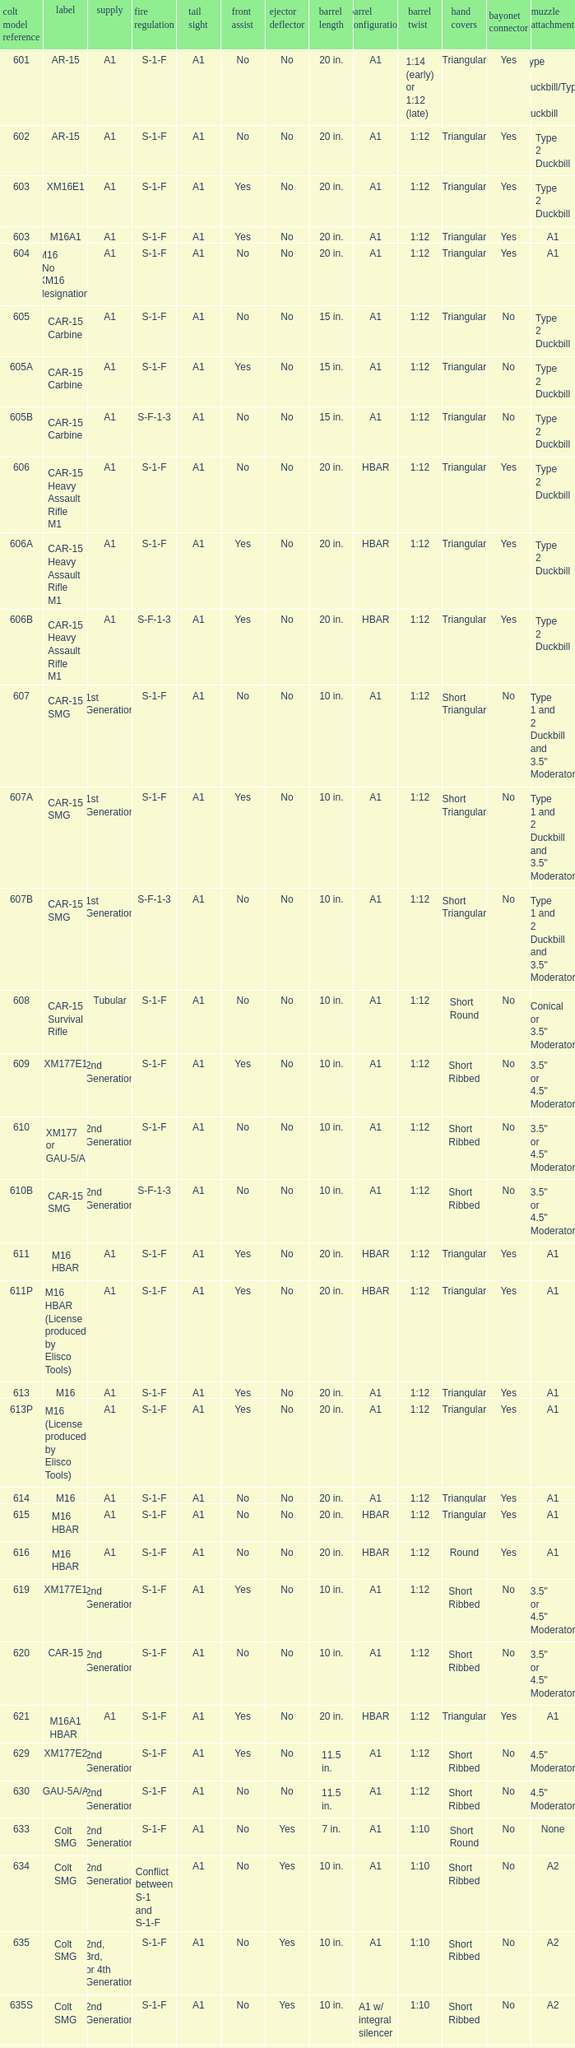What are the Colt model numbers of the models named GAU-5A/A, with no bayonet lug, no case deflector and stock of 2nd generation?  630, 649. Could you help me parse every detail presented in this table? {'header': ['colt model reference', 'label', 'supply', 'fire regulation', 'tail sight', 'front assist', 'ejector deflector', 'barrel length', 'barrel configuration', 'barrel twist', 'hand covers', 'bayonet connector', 'muzzle attachment'], 'rows': [['601', 'AR-15', 'A1', 'S-1-F', 'A1', 'No', 'No', '20 in.', 'A1', '1:14 (early) or 1:12 (late)', 'Triangular', 'Yes', 'Type 1 Duckbill/Type 2 Duckbill'], ['602', 'AR-15', 'A1', 'S-1-F', 'A1', 'No', 'No', '20 in.', 'A1', '1:12', 'Triangular', 'Yes', 'Type 2 Duckbill'], ['603', 'XM16E1', 'A1', 'S-1-F', 'A1', 'Yes', 'No', '20 in.', 'A1', '1:12', 'Triangular', 'Yes', 'Type 2 Duckbill'], ['603', 'M16A1', 'A1', 'S-1-F', 'A1', 'Yes', 'No', '20 in.', 'A1', '1:12', 'Triangular', 'Yes', 'A1'], ['604', 'M16 (No XM16 designation)', 'A1', 'S-1-F', 'A1', 'No', 'No', '20 in.', 'A1', '1:12', 'Triangular', 'Yes', 'A1'], ['605', 'CAR-15 Carbine', 'A1', 'S-1-F', 'A1', 'No', 'No', '15 in.', 'A1', '1:12', 'Triangular', 'No', 'Type 2 Duckbill'], ['605A', 'CAR-15 Carbine', 'A1', 'S-1-F', 'A1', 'Yes', 'No', '15 in.', 'A1', '1:12', 'Triangular', 'No', 'Type 2 Duckbill'], ['605B', 'CAR-15 Carbine', 'A1', 'S-F-1-3', 'A1', 'No', 'No', '15 in.', 'A1', '1:12', 'Triangular', 'No', 'Type 2 Duckbill'], ['606', 'CAR-15 Heavy Assault Rifle M1', 'A1', 'S-1-F', 'A1', 'No', 'No', '20 in.', 'HBAR', '1:12', 'Triangular', 'Yes', 'Type 2 Duckbill'], ['606A', 'CAR-15 Heavy Assault Rifle M1', 'A1', 'S-1-F', 'A1', 'Yes', 'No', '20 in.', 'HBAR', '1:12', 'Triangular', 'Yes', 'Type 2 Duckbill'], ['606B', 'CAR-15 Heavy Assault Rifle M1', 'A1', 'S-F-1-3', 'A1', 'Yes', 'No', '20 in.', 'HBAR', '1:12', 'Triangular', 'Yes', 'Type 2 Duckbill'], ['607', 'CAR-15 SMG', '1st Generation', 'S-1-F', 'A1', 'No', 'No', '10 in.', 'A1', '1:12', 'Short Triangular', 'No', 'Type 1 and 2 Duckbill and 3.5" Moderator'], ['607A', 'CAR-15 SMG', '1st Generation', 'S-1-F', 'A1', 'Yes', 'No', '10 in.', 'A1', '1:12', 'Short Triangular', 'No', 'Type 1 and 2 Duckbill and 3.5" Moderator'], ['607B', 'CAR-15 SMG', '1st Generation', 'S-F-1-3', 'A1', 'No', 'No', '10 in.', 'A1', '1:12', 'Short Triangular', 'No', 'Type 1 and 2 Duckbill and 3.5" Moderator'], ['608', 'CAR-15 Survival Rifle', 'Tubular', 'S-1-F', 'A1', 'No', 'No', '10 in.', 'A1', '1:12', 'Short Round', 'No', 'Conical or 3.5" Moderator'], ['609', 'XM177E1', '2nd Generation', 'S-1-F', 'A1', 'Yes', 'No', '10 in.', 'A1', '1:12', 'Short Ribbed', 'No', '3.5" or 4.5" Moderator'], ['610', 'XM177 or GAU-5/A', '2nd Generation', 'S-1-F', 'A1', 'No', 'No', '10 in.', 'A1', '1:12', 'Short Ribbed', 'No', '3.5" or 4.5" Moderator'], ['610B', 'CAR-15 SMG', '2nd Generation', 'S-F-1-3', 'A1', 'No', 'No', '10 in.', 'A1', '1:12', 'Short Ribbed', 'No', '3.5" or 4.5" Moderator'], ['611', 'M16 HBAR', 'A1', 'S-1-F', 'A1', 'Yes', 'No', '20 in.', 'HBAR', '1:12', 'Triangular', 'Yes', 'A1'], ['611P', 'M16 HBAR (License produced by Elisco Tools)', 'A1', 'S-1-F', 'A1', 'Yes', 'No', '20 in.', 'HBAR', '1:12', 'Triangular', 'Yes', 'A1'], ['613', 'M16', 'A1', 'S-1-F', 'A1', 'Yes', 'No', '20 in.', 'A1', '1:12', 'Triangular', 'Yes', 'A1'], ['613P', 'M16 (License produced by Elisco Tools)', 'A1', 'S-1-F', 'A1', 'Yes', 'No', '20 in.', 'A1', '1:12', 'Triangular', 'Yes', 'A1'], ['614', 'M16', 'A1', 'S-1-F', 'A1', 'No', 'No', '20 in.', 'A1', '1:12', 'Triangular', 'Yes', 'A1'], ['615', 'M16 HBAR', 'A1', 'S-1-F', 'A1', 'No', 'No', '20 in.', 'HBAR', '1:12', 'Triangular', 'Yes', 'A1'], ['616', 'M16 HBAR', 'A1', 'S-1-F', 'A1', 'No', 'No', '20 in.', 'HBAR', '1:12', 'Round', 'Yes', 'A1'], ['619', 'XM177E1', '2nd Generation', 'S-1-F', 'A1', 'Yes', 'No', '10 in.', 'A1', '1:12', 'Short Ribbed', 'No', '3.5" or 4.5" Moderator'], ['620', 'CAR-15', '2nd Generation', 'S-1-F', 'A1', 'No', 'No', '10 in.', 'A1', '1:12', 'Short Ribbed', 'No', '3.5" or 4.5" Moderator'], ['621', 'M16A1 HBAR', 'A1', 'S-1-F', 'A1', 'Yes', 'No', '20 in.', 'HBAR', '1:12', 'Triangular', 'Yes', 'A1'], ['629', 'XM177E2', '2nd Generation', 'S-1-F', 'A1', 'Yes', 'No', '11.5 in.', 'A1', '1:12', 'Short Ribbed', 'No', '4.5" Moderator'], ['630', 'GAU-5A/A', '2nd Generation', 'S-1-F', 'A1', 'No', 'No', '11.5 in.', 'A1', '1:12', 'Short Ribbed', 'No', '4.5" Moderator'], ['633', 'Colt SMG', '2nd Generation', 'S-1-F', 'A1', 'No', 'Yes', '7 in.', 'A1', '1:10', 'Short Round', 'No', 'None'], ['634', 'Colt SMG', '2nd Generation', 'Conflict between S-1 and S-1-F', 'A1', 'No', 'Yes', '10 in.', 'A1', '1:10', 'Short Ribbed', 'No', 'A2'], ['635', 'Colt SMG', '2nd, 3rd, or 4th Generation', 'S-1-F', 'A1', 'No', 'Yes', '10 in.', 'A1', '1:10', 'Short Ribbed', 'No', 'A2'], ['635S', 'Colt SMG', '2nd Generation', 'S-1-F', 'A1', 'No', 'Yes', '10 in.', 'A1 w/ integral silencer', '1:10', 'Short Ribbed', 'No', 'A2'], ['639', 'XM177E2', '2nd Generation', 'S-1-F', 'A1', 'Yes', 'No', '11.5 in.', 'A1', '1:12', 'Short Ribbed', 'No', '4.5" Moderator or A1'], ['639', 'Colt SMG', '2nd', 'S-1-3', 'A1', 'No', 'Yes', '10 in.', 'A1 w/ integral silencer', '1:10', 'Short Ribbed', 'No', 'A2'], ['640', 'XM177E2', '2nd Generation', 'S-1-F', 'A1', 'No', 'No', '11.5 in.', 'A1', '1:12', 'Short Ribbed', 'No', '4.5" Moderator or A1'], ['645', 'M16A1E1/M16A2', 'A2', 'S-1-3', 'A2', 'Yes', 'Yes', '20 in.', 'A2', '1:7', 'Ribbed', 'Yes', 'A2'], ['645E', 'M16A2E1', 'Flattop (w/ flip down front sight)', 'S-1-3', 'A2', 'Yes', 'Yes', '20 in.', 'A2', '1:7', 'Ribbed', 'Yes', 'A2'], ['646', 'M16A2E3/M16A3', 'A2', 'S-1-F', 'A2', 'Yes', 'Yes', '20 in.', 'A2', '1:7', 'Ribbed', 'Yes', 'A2'], ['649', 'GAU-5A/A', '2nd Generation', 'S-1-F', 'A1', 'No', 'No', '11.5 in.', 'A1', '1:12', 'Short Ribbed', 'No', '4.5" Moderator'], ['650', 'M16A1 carbine', 'A1', 'S-1-F', 'A1', 'Yes', 'No', '14.5 in.', 'A1', '1:12', 'Short Ribbed', 'Yes', 'A1'], ['651', 'M16A1 carbine', 'A1', 'S-1-F', 'A1', 'Yes', 'No', '14.5 in.', 'A1', '1:12', 'Short Ribbed', 'Yes', 'A1'], ['652', 'M16A1 carbine', 'A1', 'S-1-F', 'A1', 'No', 'No', '14.5 in.', 'A1', '1:12', 'Short Ribbed', 'Yes', 'A1'], ['653', 'M16A1 carbine', '2nd Generation', 'S-1-F', 'A1', 'Yes', 'No', '14.5 in.', 'A1', '1:12', 'Short Ribbed', 'Yes', 'A1'], ['653P', 'M16A1 carbine (License produced by Elisco Tools)', '2nd Generation', 'S-1-F', 'A1', 'Yes', 'No', '14.5 in.', 'A1', '1:12', 'Short Ribbed', 'Yes', 'A1'], ['654', 'M16A1 carbine', '2nd Generation', 'S-1-F', 'A1', 'No', 'No', '14.5 in.', 'A1', '1:12', 'Short Ribbed', 'Yes', 'A1'], ['656', 'M16A1 Special Low Profile', 'A1', 'S-1-F', 'Flattop', 'Yes', 'No', '20 in.', 'HBAR', '1:12', 'Triangular', 'Yes', 'A1'], ['701', 'M16A2', 'A2', 'S-1-F', 'A2', 'Yes', 'Yes', '20 in.', 'A2', '1:7', 'Ribbed', 'Yes', 'A2'], ['702', 'M16A2', 'A2', 'S-1-3', 'A2', 'Yes', 'Yes', '20 in.', 'A2', '1:7', 'Ribbed', 'Yes', 'A2'], ['703', 'M16A2', 'A2', 'S-1-F', 'A2', 'Yes', 'Yes', '20 in.', 'A1', '1:7', 'Ribbed', 'Yes', 'A2'], ['705', 'M16A2', 'A2', 'S-1-3', 'A2', 'Yes', 'Yes', '20 in.', 'A2', '1:7', 'Ribbed', 'Yes', 'A2'], ['707', 'M16A2', 'A2', 'S-1-3', 'A2', 'Yes', 'Yes', '20 in.', 'A1', '1:7', 'Ribbed', 'Yes', 'A2'], ['711', 'M16A2', 'A2', 'S-1-F', 'A1', 'Yes', 'No and Yes', '20 in.', 'A1', '1:7', 'Ribbed', 'Yes', 'A2'], ['713', 'M16A2', 'A2', 'S-1-3', 'A2', 'Yes', 'Yes', '20 in.', 'A2', '1:7', 'Ribbed', 'Yes', 'A2'], ['719', 'M16A2', 'A2', 'S-1-3', 'A2', 'Yes', 'Yes', '20 in.', 'A1', '1:7', 'Ribbed', 'Yes', 'A2'], ['720', 'XM4 Carbine', '3rd Generation', 'S-1-3', 'A2', 'Yes', 'Yes', '14.5 in.', 'M4', '1:7', 'Short Ribbed', 'Yes', 'A2'], ['723', 'M16A2 carbine', '3rd Generation', 'S-1-F', 'A1', 'Yes', 'Yes', '14.5 in.', 'A1', '1:7', 'Short Ribbed', 'Yes', 'A1'], ['725A', 'M16A2 carbine', '3rd Generation', 'S-1-F', 'A1', 'Yes', 'Yes', '14.5 in.', 'A1', '1:7', 'Short Ribbed', 'Yes', 'A2'], ['725B', 'M16A2 carbine', '3rd Generation', 'S-1-F', 'A1', 'Yes', 'Yes', '14.5 in.', 'A2', '1:7', 'Short Ribbed', 'Yes', 'A2'], ['726', 'M16A2 carbine', '3rd Generation', 'S-1-F', 'A1', 'Yes', 'Yes', '14.5 in.', 'A1', '1:7', 'Short Ribbed', 'Yes', 'A1'], ['727', 'M16A2 carbine', '3rd Generation', 'S-1-F', 'A2', 'Yes', 'Yes', '14.5 in.', 'M4', '1:7', 'Short Ribbed', 'Yes', 'A2'], ['728', 'M16A2 carbine', '3rd Generation', 'S-1-F', 'A2', 'Yes', 'Yes', '14.5 in.', 'M4', '1:7', 'Short Ribbed', 'Yes', 'A2'], ['733', 'M16A2 Commando / M4 Commando', '3rd or 4th Generation', 'S-1-F', 'A1 or A2', 'Yes', 'Yes or No', '11.5 in.', 'A1 or A2', '1:7', 'Short Ribbed', 'No', 'A1 or A2'], ['733A', 'M16A2 Commando / M4 Commando', '3rd or 4th Generation', 'S-1-3', 'A1 or A2', 'Yes', 'Yes or No', '11.5 in.', 'A1 or A2', '1:7', 'Short Ribbed', 'No', 'A1 or A2'], ['734', 'M16A2 Commando', '3rd Generation', 'S-1-F', 'A1 or A2', 'Yes', 'Yes or No', '11.5 in.', 'A1 or A2', '1:7', 'Short Ribbed', 'No', 'A1 or A2'], ['734A', 'M16A2 Commando', '3rd Generation', 'S-1-3', 'A1 or A2', 'Yes', 'Yes or No', '11.5 in.', 'A1 or A2', '1:7', 'Short Ribbed', 'No', 'A1 or A2'], ['735', 'M16A2 Commando / M4 Commando', '3rd or 4th Generation', 'S-1-3', 'A1 or A2', 'Yes', 'Yes or No', '11.5 in.', 'A1 or A2', '1:7', 'Short Ribbed', 'No', 'A1 or A2'], ['737', 'M16A2', 'A2', 'S-1-3', 'A2', 'Yes', 'Yes', '20 in.', 'HBAR', '1:7', 'Ribbed', 'Yes', 'A2'], ['738', 'M4 Commando Enhanced', '4th Generation', 'S-1-3-F', 'A2', 'Yes', 'Yes', '11.5 in.', 'A2', '1:7', 'Short Ribbed', 'No', 'A1 or A2'], ['741', 'M16A2', 'A2', 'S-1-F', 'A2', 'Yes', 'Yes', '20 in.', 'HBAR', '1:7', 'Ribbed', 'Yes', 'A2'], ['742', 'M16A2 (Standard w/ bipod)', 'A2', 'S-1-F', 'A2', 'Yes', 'Yes', '20 in.', 'HBAR', '1:7', 'Ribbed', 'Yes', 'A2'], ['745', 'M16A2 (Standard w/ bipod)', 'A2', 'S-1-3', 'A2', 'Yes', 'Yes', '20 in.', 'HBAR', '1:7', 'Ribbed', 'Yes', 'A2'], ['746', 'M16A2 (Standard w/ bipod)', 'A2', 'S-1-3', 'A2', 'Yes', 'Yes', '20 in.', 'HBAR', '1:7', 'Ribbed', 'Yes', 'A2'], ['750', 'LMG (Colt/ Diemaco project)', 'A2', 'S-F', 'A2', 'Yes', 'Yes', '20 in.', 'HBAR', '1:7', 'Square LMG', 'Yes', 'A2'], ['777', 'M4 Carbine', '4th Generation', 'S-1-3', 'A2', 'Yes', 'Yes', '14.5 in.', 'M4', '1:7', 'M4', 'Yes', 'A2'], ['778', 'M4 Carbine Enhanced', '4th Generation', 'S-1-3-F', 'A2', 'Yes', 'Yes', '14.5 in.', 'M4', '1:7', 'M4', 'Yes', 'A2'], ['779', 'M4 Carbine', '4th Generation', 'S-1-F', 'A2', 'Yes', 'Yes', '14.5 in.', 'M4', '1:7', 'M4', 'Yes', 'A2'], ['901', 'M16A3', 'A2', 'S-1-F', 'Flattop', 'Yes', 'Yes', '20 in.', 'A2', '1:7', 'Ribbed', 'Yes', 'A2'], ['905', 'M16A4', 'A2', 'S-1-3', 'Flattop', 'Yes', 'Yes', '20 in.', 'A2', '1:7', 'Ribbed', 'Yes', 'A2'], ['920', 'M4 Carbine', '3rd and 4th Generation', 'S-1-3', 'Flattop', 'Yes', 'Yes', '14.5 in.', 'M4', '1:7', 'M4', 'Yes', 'A2'], ['921', 'M4E1/A1 Carbine', '4th Generation', 'S-1-F', 'Flattop', 'Yes', 'Yes', '14.5 in.', 'M4', '1:7', 'M4', 'Yes', 'A2'], ['921HB', 'M4A1 Carbine', '4th Generation', 'S-1-F', 'Flattop', 'Yes', 'Yes', '14.5 in.', 'M4 HBAR', '1:7', 'M4', 'Yes', 'A2'], ['925', 'M4E2 Carbine', '3rd or 4th Generation', 'S-1-3', 'Flattop', 'Yes', 'Yes', '14.5 in.', 'M4', '1:7', 'M4', 'Yes', 'A2'], ['927', 'M4 Carbine', '4th Generation', 'S-1-F', 'Flattop', 'Yes', 'Yes', '14.5 in.', 'M4', '1:7', 'M4', 'Yes', 'A2'], ['933', 'M4 Commando', '4th Generation', 'S-1-F', 'Flattop', 'Yes', 'Yes', '11.5 in.', 'A1 or A2', '1:7', 'Short Ribbed', 'No', 'A2'], ['935', 'M4 Commando', '4th Generation', 'S-1-3', 'Flattop', 'Yes', 'Yes', '11.5 in.', 'A1 or A2', '1:7', 'Short Ribbed', 'No', 'A2'], ['938', 'M4 Commando Enhanced', '4th Generation', 'S-1-3-F', 'Flattop', 'Yes', 'Yes', '11.5 in.', 'A2', '1:7', 'M4', 'No', 'A2'], ['977', 'M4 Carbine', '4th Generation', 'S-1-3', 'Flattop', 'Yes', 'Yes', '14.5 in.', 'M4', '1:7', 'M4', 'Yes', 'A2'], ['941', 'M16A3', 'A2', 'S-1-F', 'Flattop', 'Yes', 'Yes', '20 in.', 'HBAR', '1:7', 'Ribbed', 'Yes', 'A2'], ['942', 'M16A3 (Standard w/ bipod)', 'A2', 'S-1-F', 'Flattop', 'Yes', 'Yes', '20 in.', 'HBAR', '1:7', 'Ribbed', 'Yes', 'A2'], ['945', 'M16A2E4/M16A4', 'A2', 'S-1-3', 'Flattop', 'Yes', 'Yes', '20 in.', 'A2', '1:7', 'Ribbed', 'Yes', 'A2'], ['950', 'LMG (Colt/ Diemaco project)', 'A2', 'S-F', 'Flattop', 'Yes', 'Yes', '20 in.', 'HBAR', '1:7', 'Square LMG', 'Yes', 'A2'], ['"977"', 'M4 Carbine', '4th Generation', 'S-1-3', 'Flattop', 'Yes', 'Yes', '14.5 in.', 'M4', '1:7', 'M4', 'Yes', 'A2'], ['978', 'M4 Carbine Enhanced', '4th Generation', 'S-1-3-F', 'Flattop', 'Yes', 'Yes', '14.5 in.', 'M4', '1:7', 'M4', 'Yes', 'A2'], ['979', 'M4A1 Carbine', '4th Generation', 'S-1-F', 'Flattop', 'Yes', 'Yes', '14.5 in.', 'M4', '1:7', 'M4', 'Yes', 'A2']]} 